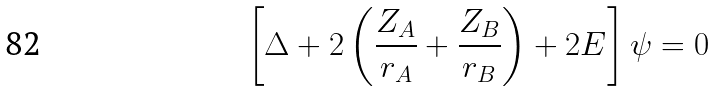Convert formula to latex. <formula><loc_0><loc_0><loc_500><loc_500>\left [ \Delta + 2 \left ( \frac { Z _ { A } } { r _ { A } } + \frac { Z _ { B } } { r _ { B } } \right ) + 2 E \right ] \psi = 0</formula> 